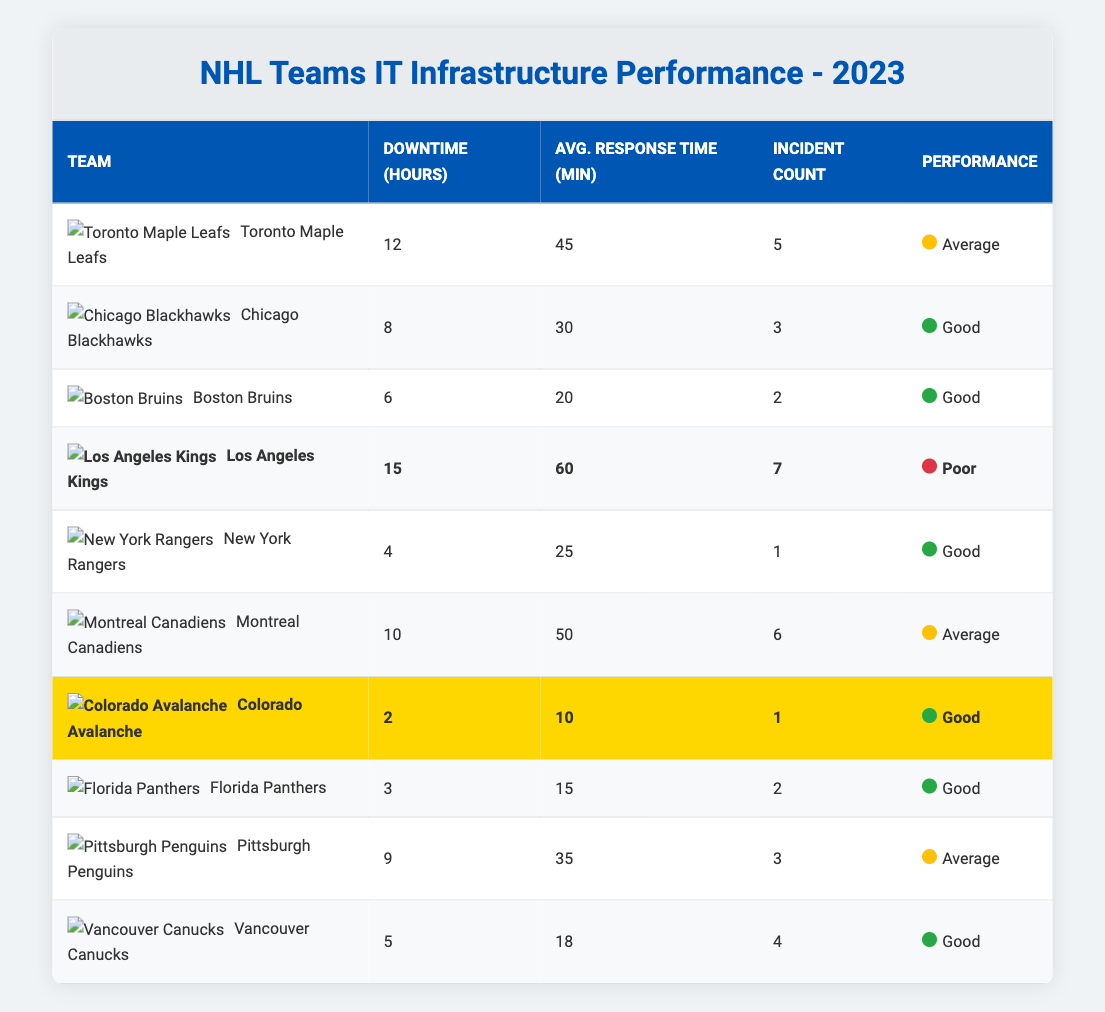What team had the highest downtime hours in 2023? The team with the highest downtime hours is the Los Angeles Kings with 15 hours. By referring to the "Downtime (Hours)" column, it's clear that no other team exceeds this number.
Answer: Los Angeles Kings What is the average response time for the teams that had downtime hours less than 5? Only the New York Rangers had downtime hours less than 5, with an average response time of 25 minutes. The average response time in this case is therefore just this single value, as there are no other teams to average with.
Answer: 25 minutes How many incidents did the Montreal Canadiens experience? The Incident Count for the Montreal Canadiens is listed as 6 in the Incident Count column. This can be directly obtained from the table.
Answer: 6 incidents Did any team have a performance categorized as poor? Yes, the Los Angeles Kings are categorized as poor in performance, as noted in their row under the Performance column.
Answer: Yes Which teams had an average response time greater than 40 minutes? The Los Angeles Kings and Toronto Maple Leafs both have average response times greater than 40 minutes, with 60 minutes and 45 minutes respectively. This can be deduced by scanning the Average Response Time (Min) column for values above 40.
Answer: Los Angeles Kings, Toronto Maple Leafs What is the total downtime for all the teams? To find the total downtime, we sum all the downtime hours: 12 + 8 + 6 + 15 + 4 + 10 + 2 + 3 + 9 + 5 = 74 hours total. This involves adding each value in the Downtime (Hours) column.
Answer: 74 hours Which team had the least downtime, and what was it? The team with the least downtime is the Colorado Avalanche with only 2 hours of downtime, which can be determined by identifying the smallest number in the Downtime (Hours) column.
Answer: Colorado Avalanche, 2 hours How many teams experienced 3 or more incidents? There are 4 teams that experienced 3 or more incidents: Los Angeles Kings (7), Montreal Canadiens (6), Toronto Maple Leafs (5), and Pittsburgh Penguins (3). This can be verified by counting the Incident Count values that are 3 or greater.
Answer: 4 teams What is the difference in average response time between the team with the most downtime and the team with the least downtime? The Los Angeles Kings have an average response time of 60 minutes and the Colorado Avalanche have an average response time of 10 minutes. The difference is 60 - 10 = 50 minutes. This involves identifying the respective average response times and performing the subtraction.
Answer: 50 minutes Which team had the most incidents, and how does it compare to the team with the lowest incident count? The Los Angeles Kings had the most incidents with 7, while the New York Rangers had the lowest with 1. The comparison shows a difference of 7 - 1 = 6 incidents. Thus, the Los Angeles Kings had significantly more incidents than the New York Rangers.
Answer: Los Angeles Kings, 7 incidents, difference of 6 